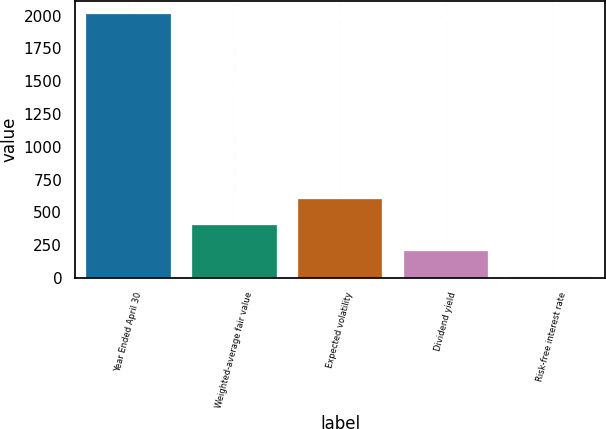Convert chart. <chart><loc_0><loc_0><loc_500><loc_500><bar_chart><fcel>Year Ended April 30<fcel>Weighted-average fair value<fcel>Expected volatility<fcel>Dividend yield<fcel>Risk-free interest rate<nl><fcel>2009<fcel>403.84<fcel>604.49<fcel>203.19<fcel>2.54<nl></chart> 